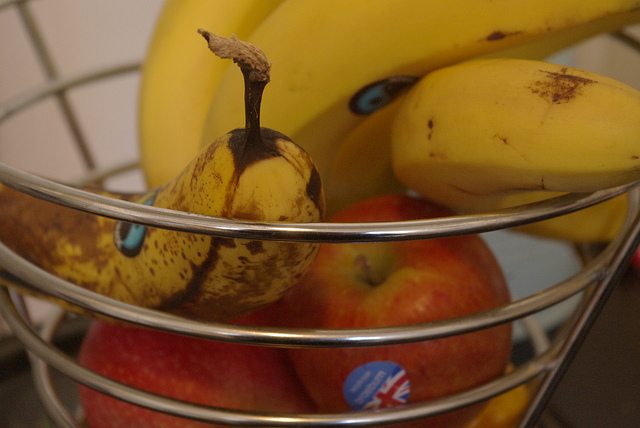<image>What country's flag is represented on the sticker of the apple? I am not sure which country's flag is represented on the sticker of the apple. It might be the flag of England, UK, United Kingdom, Great Britain, or Britain. What country's flag is represented on the sticker of the apple? I don't know which country's flag is represented on the sticker of the apple. It can be England, United Kingdom, Great Britain, or Britain. 